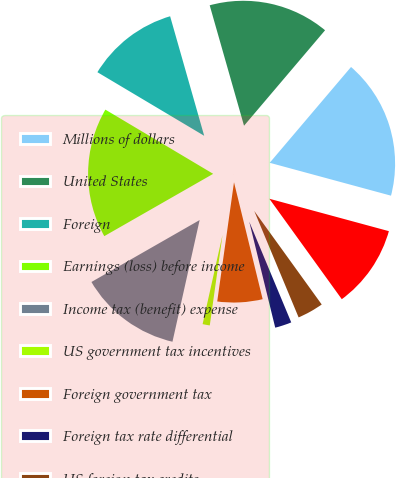Convert chart. <chart><loc_0><loc_0><loc_500><loc_500><pie_chart><fcel>Millions of dollars<fcel>United States<fcel>Foreign<fcel>Earnings (loss) before income<fcel>Income tax (benefit) expense<fcel>US government tax incentives<fcel>Foreign government tax<fcel>Foreign tax rate differential<fcel>US foreign tax credits<fcel>Valuation allowances<nl><fcel>18.01%<fcel>15.62%<fcel>12.03%<fcel>16.82%<fcel>13.23%<fcel>1.27%<fcel>6.05%<fcel>2.46%<fcel>3.66%<fcel>10.84%<nl></chart> 